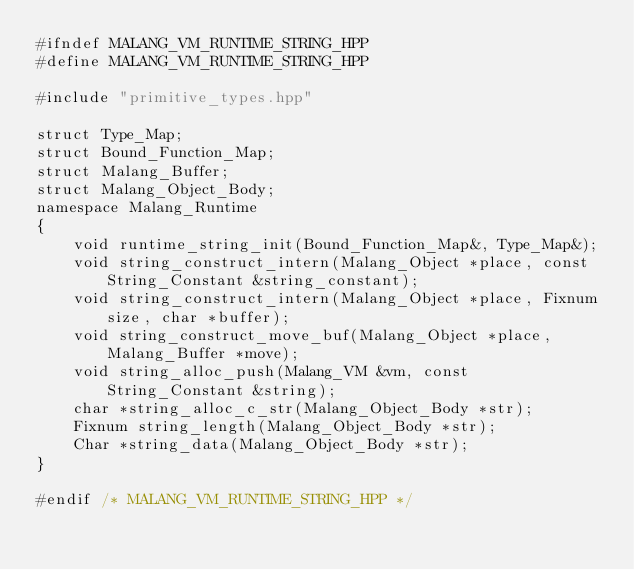<code> <loc_0><loc_0><loc_500><loc_500><_C++_>#ifndef MALANG_VM_RUNTIME_STRING_HPP
#define MALANG_VM_RUNTIME_STRING_HPP

#include "primitive_types.hpp"

struct Type_Map;
struct Bound_Function_Map;
struct Malang_Buffer;
struct Malang_Object_Body;
namespace Malang_Runtime
{
    void runtime_string_init(Bound_Function_Map&, Type_Map&);
    void string_construct_intern(Malang_Object *place, const String_Constant &string_constant);
    void string_construct_intern(Malang_Object *place, Fixnum size, char *buffer);
    void string_construct_move_buf(Malang_Object *place, Malang_Buffer *move);
    void string_alloc_push(Malang_VM &vm, const String_Constant &string);
    char *string_alloc_c_str(Malang_Object_Body *str);
    Fixnum string_length(Malang_Object_Body *str);
    Char *string_data(Malang_Object_Body *str);
}

#endif /* MALANG_VM_RUNTIME_STRING_HPP */
</code> 